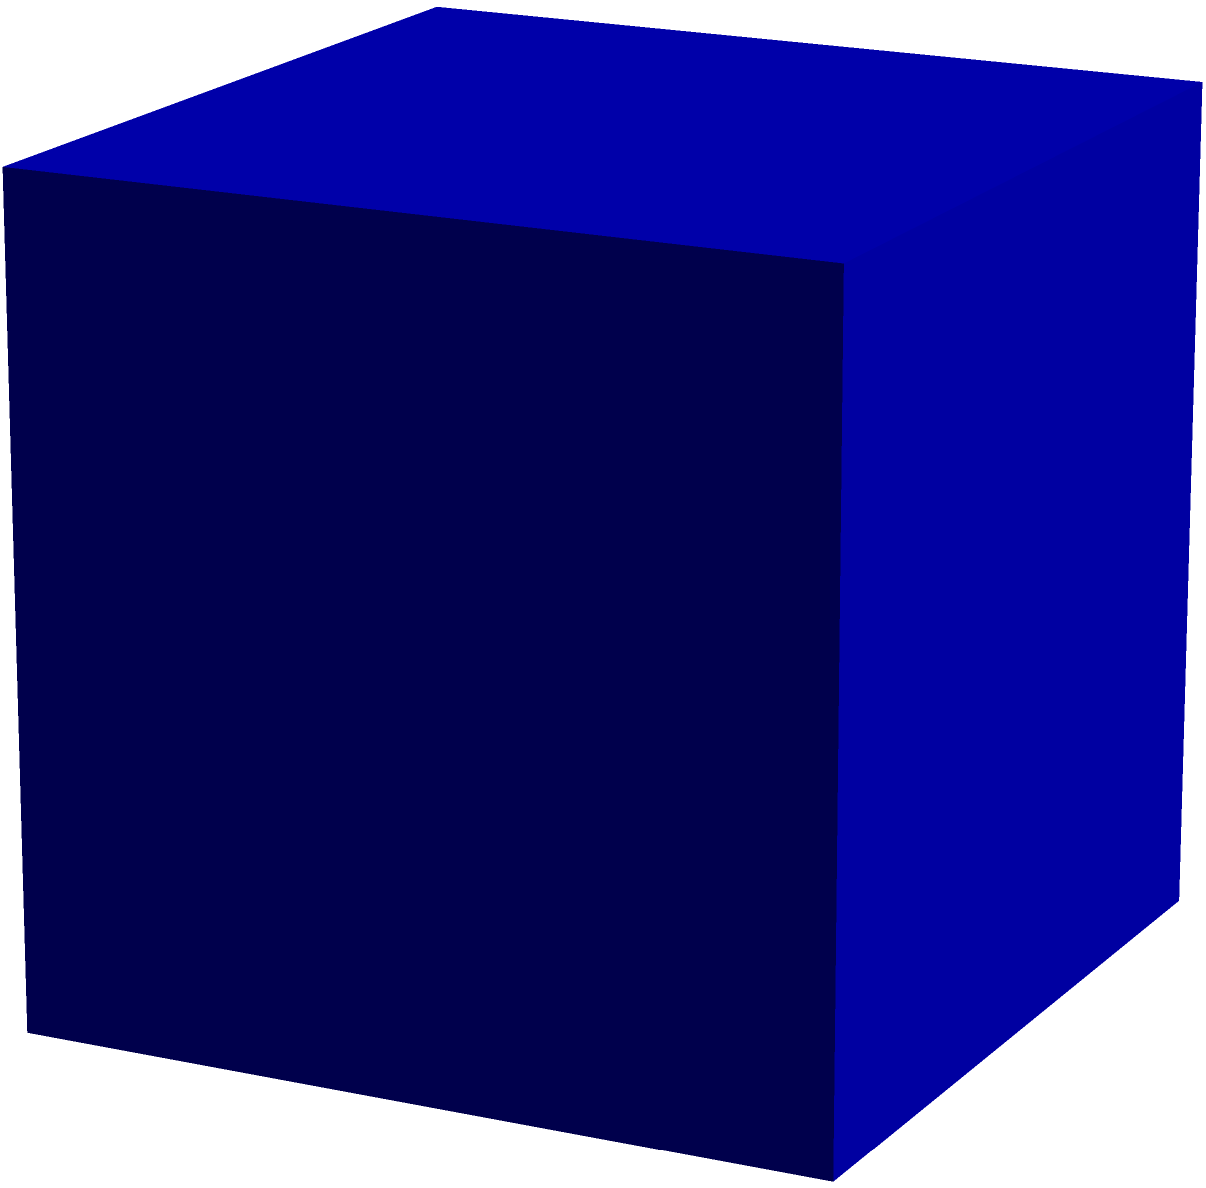Look at the image of a cube. Can you count and tell how many faces, edges, and vertices this shape has? Let's count each element of the cube step by step:

1. Faces:
   - We can see 3 faces clearly in the image (front, top, and right side).
   - But we know a cube has opposite faces, so there are 3 more faces we can't see (back, bottom, and left side).
   - Total faces: 3 visible + 3 hidden = 6 faces

2. Edges:
   - Count the visible edges: 9 edges can be seen in the image.
   - There are 3 hidden edges at the back of the cube.
   - Total edges: 9 visible + 3 hidden = 12 edges

3. Vertices:
   - Count the red dots in the image: There are 7 visible vertices.
   - There is 1 hidden vertex at the back of the cube.
   - Total vertices: 7 visible + 1 hidden = 8 vertices

Therefore, a cube has 6 faces, 12 edges, and 8 vertices.
Answer: 6 faces, 12 edges, 8 vertices 